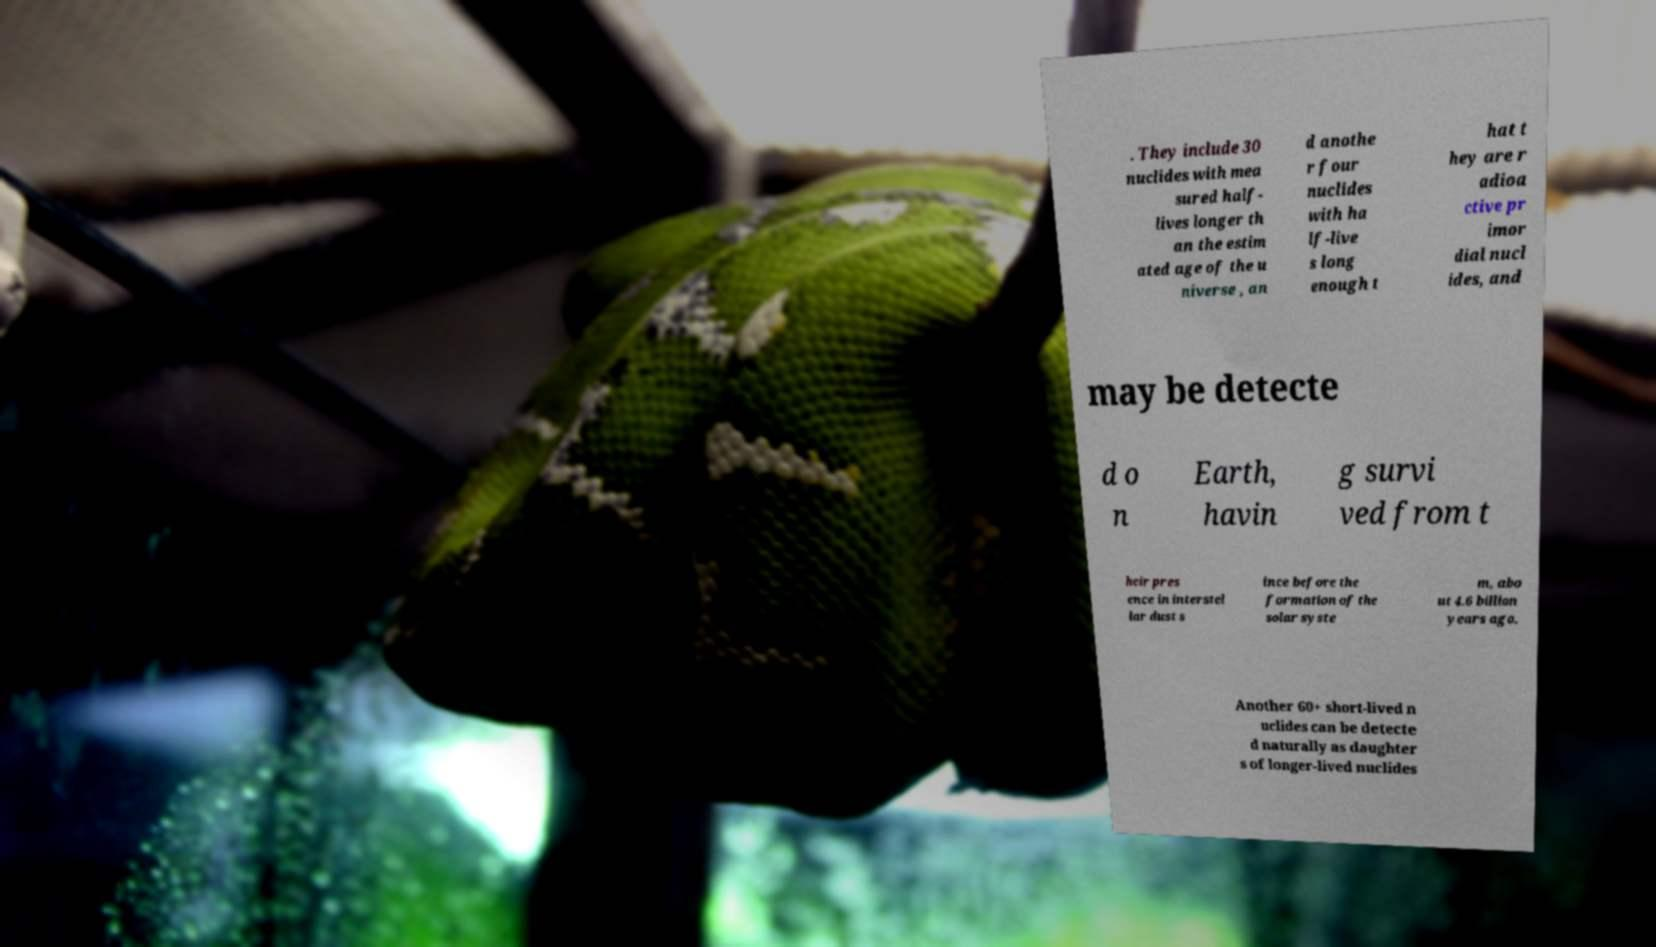For documentation purposes, I need the text within this image transcribed. Could you provide that? . They include 30 nuclides with mea sured half- lives longer th an the estim ated age of the u niverse , an d anothe r four nuclides with ha lf-live s long enough t hat t hey are r adioa ctive pr imor dial nucl ides, and may be detecte d o n Earth, havin g survi ved from t heir pres ence in interstel lar dust s ince before the formation of the solar syste m, abo ut 4.6 billion years ago. Another 60+ short-lived n uclides can be detecte d naturally as daughter s of longer-lived nuclides 